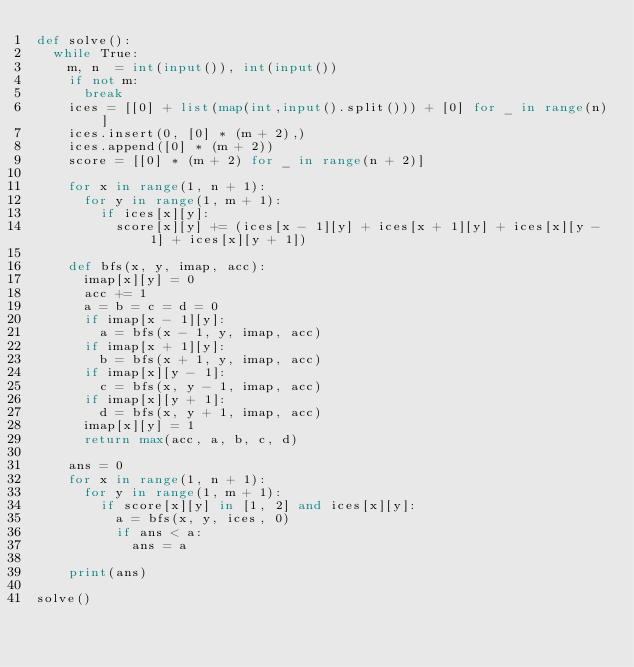<code> <loc_0><loc_0><loc_500><loc_500><_Python_>def solve():
  while True:
    m, n  = int(input()), int(input())
    if not m:
      break
    ices = [[0] + list(map(int,input().split())) + [0] for _ in range(n)]
    ices.insert(0, [0] * (m + 2),)
    ices.append([0] * (m + 2))
    score = [[0] * (m + 2) for _ in range(n + 2)]
    
    for x in range(1, n + 1):
      for y in range(1, m + 1):
        if ices[x][y]:
          score[x][y] += (ices[x - 1][y] + ices[x + 1][y] + ices[x][y - 1] + ices[x][y + 1])
    
    def bfs(x, y, imap, acc):
      imap[x][y] = 0
      acc += 1
      a = b = c = d = 0
      if imap[x - 1][y]:
        a = bfs(x - 1, y, imap, acc)
      if imap[x + 1][y]:
        b = bfs(x + 1, y, imap, acc)
      if imap[x][y - 1]:
        c = bfs(x, y - 1, imap, acc)
      if imap[x][y + 1]:
        d = bfs(x, y + 1, imap, acc)
      imap[x][y] = 1
      return max(acc, a, b, c, d)
    
    ans = 0
    for x in range(1, n + 1):
      for y in range(1, m + 1):
        if score[x][y] in [1, 2] and ices[x][y]:
          a = bfs(x, y, ices, 0)
          if ans < a:
            ans = a
    
    print(ans)

solve()
</code> 